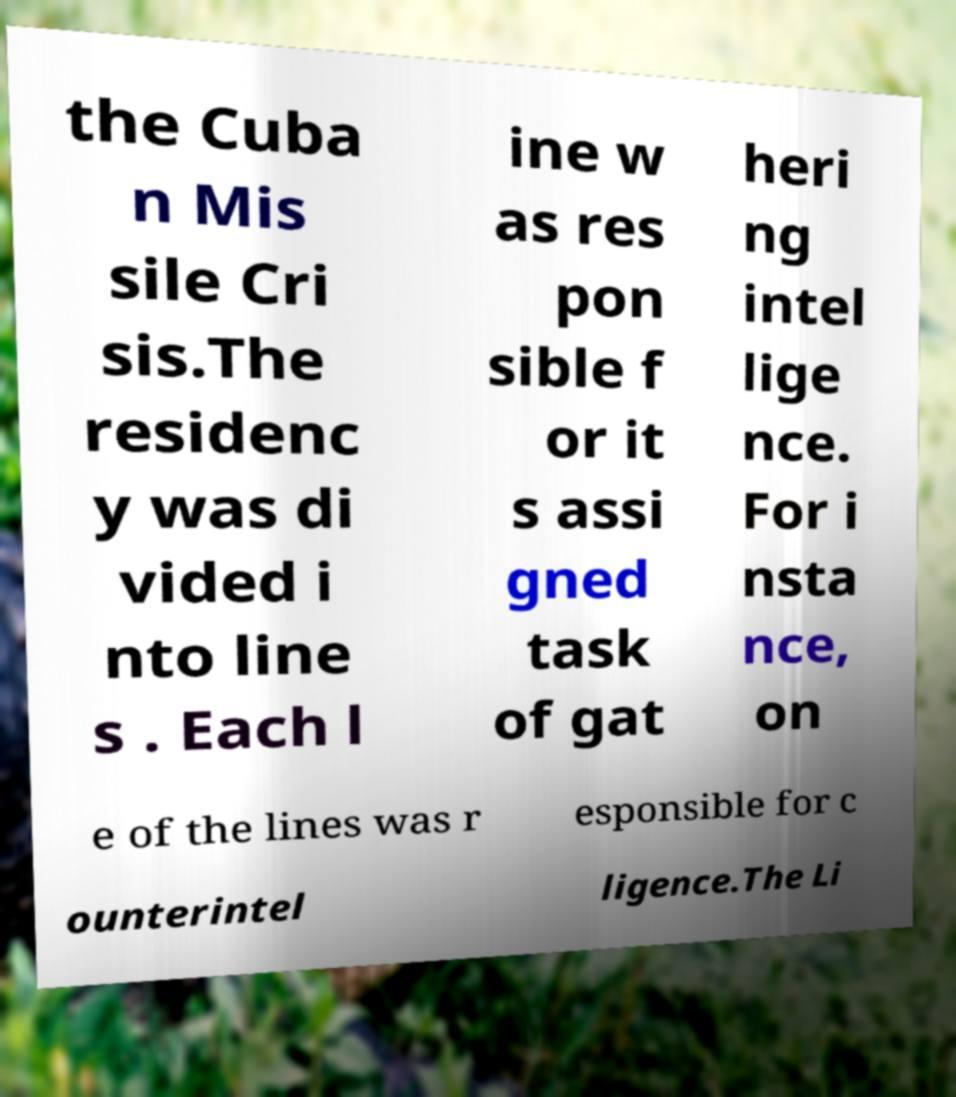Could you assist in decoding the text presented in this image and type it out clearly? the Cuba n Mis sile Cri sis.The residenc y was di vided i nto line s . Each l ine w as res pon sible f or it s assi gned task of gat heri ng intel lige nce. For i nsta nce, on e of the lines was r esponsible for c ounterintel ligence.The Li 